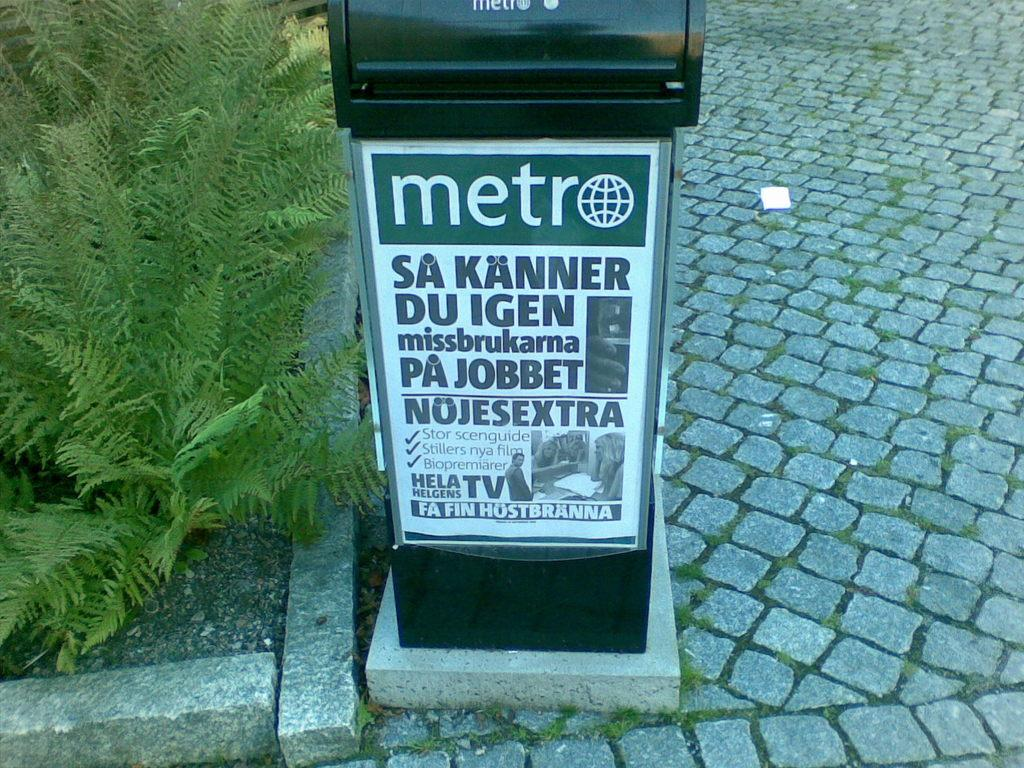<image>
Create a compact narrative representing the image presented. A Metro advertisement in Sweden is outdoors on a brick path. 